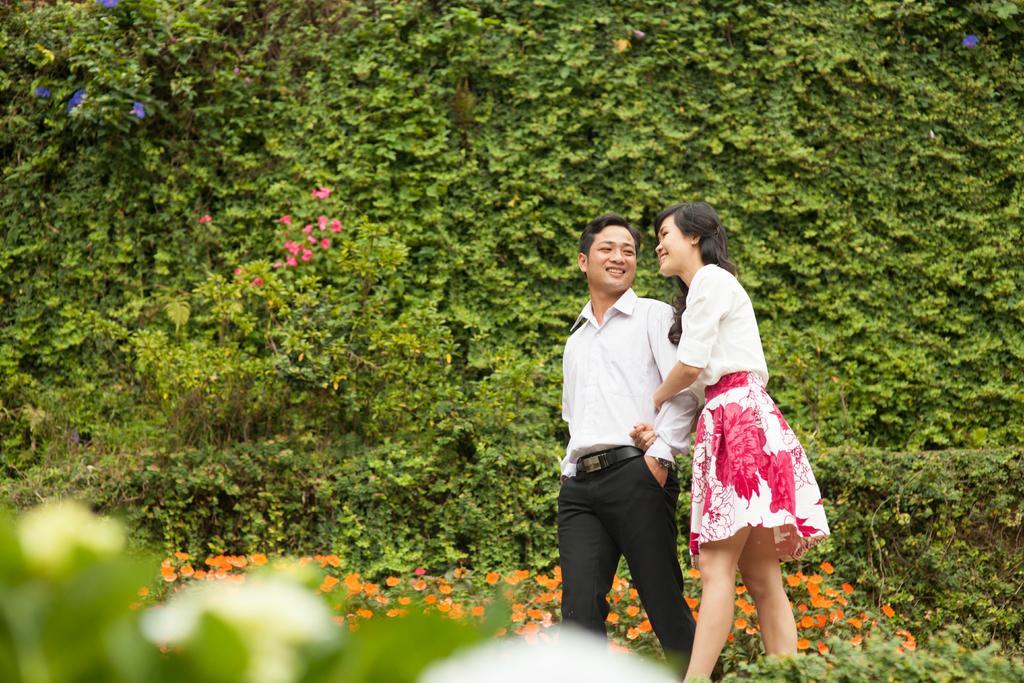Please provide a concise description of this image. This image consists of a man and a woman walking. At the bottom, there are small plants along with orange flowers. In the background, there are many plants in green color. 